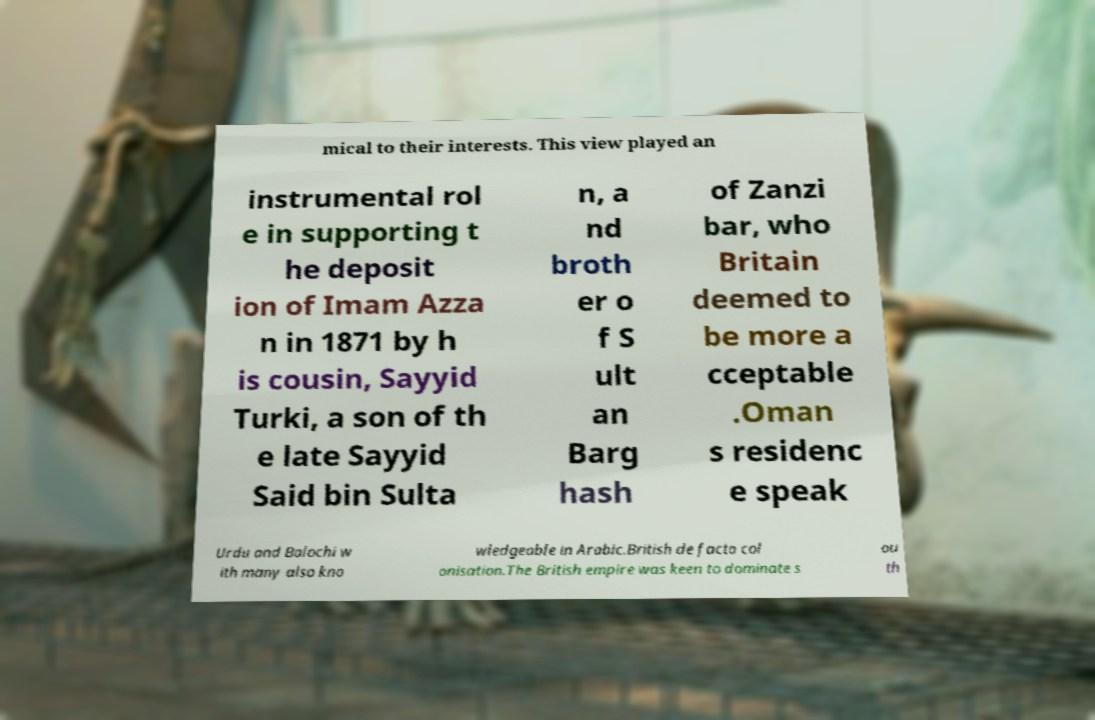Could you extract and type out the text from this image? mical to their interests. This view played an instrumental rol e in supporting t he deposit ion of Imam Azza n in 1871 by h is cousin, Sayyid Turki, a son of th e late Sayyid Said bin Sulta n, a nd broth er o f S ult an Barg hash of Zanzi bar, who Britain deemed to be more a cceptable .Oman s residenc e speak Urdu and Balochi w ith many also kno wledgeable in Arabic.British de facto col onisation.The British empire was keen to dominate s ou th 